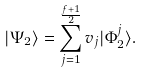<formula> <loc_0><loc_0><loc_500><loc_500>| \Psi _ { 2 } \rangle = \sum _ { j = 1 } ^ { \frac { f + 1 } { 2 } } v _ { j } | \Phi _ { 2 } ^ { j } \rangle .</formula> 